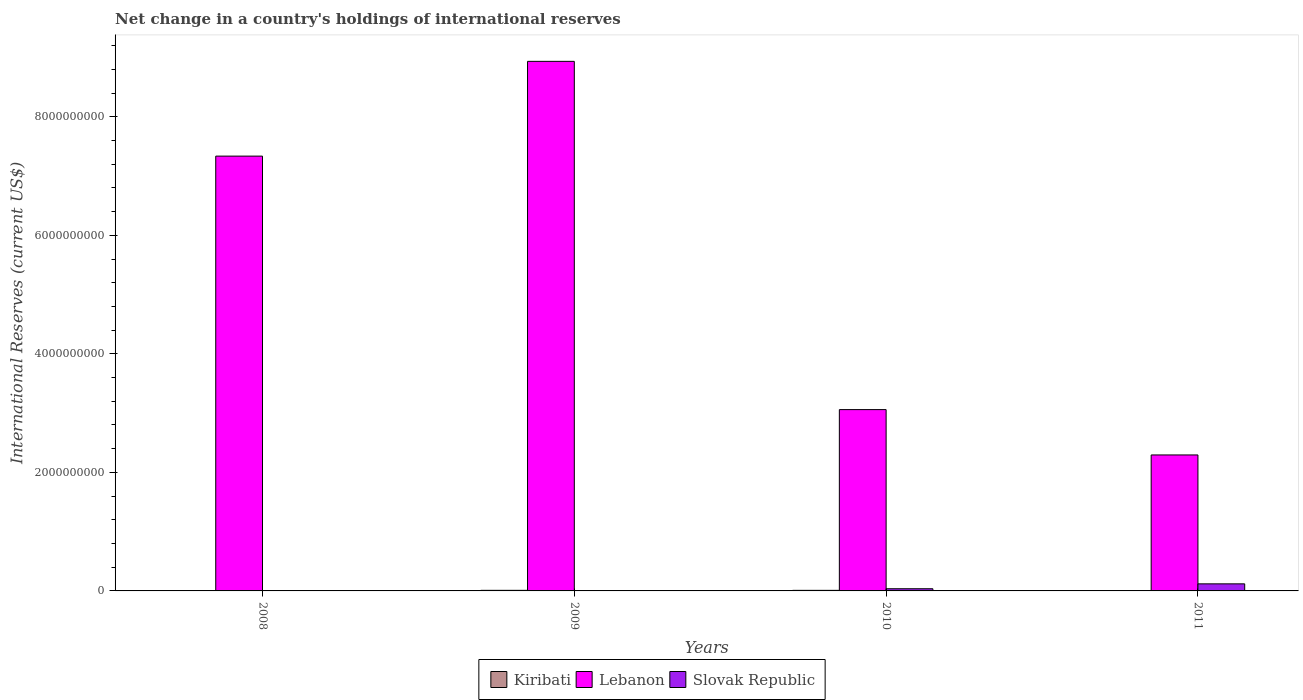How many different coloured bars are there?
Make the answer very short. 3. Are the number of bars per tick equal to the number of legend labels?
Keep it short and to the point. No. Are the number of bars on each tick of the X-axis equal?
Your answer should be very brief. No. How many bars are there on the 3rd tick from the left?
Keep it short and to the point. 3. How many bars are there on the 4th tick from the right?
Give a very brief answer. 2. In how many cases, is the number of bars for a given year not equal to the number of legend labels?
Provide a succinct answer. 2. Across all years, what is the maximum international reserves in Slovak Republic?
Offer a very short reply. 1.19e+08. What is the total international reserves in Lebanon in the graph?
Provide a short and direct response. 2.16e+1. What is the difference between the international reserves in Kiribati in 2008 and that in 2009?
Offer a very short reply. -3.36e+06. What is the difference between the international reserves in Lebanon in 2010 and the international reserves in Kiribati in 2009?
Offer a terse response. 3.05e+09. What is the average international reserves in Lebanon per year?
Your answer should be very brief. 5.41e+09. In the year 2009, what is the difference between the international reserves in Kiribati and international reserves in Lebanon?
Make the answer very short. -8.93e+09. What is the ratio of the international reserves in Kiribati in 2010 to that in 2011?
Make the answer very short. 4.87. Is the difference between the international reserves in Kiribati in 2009 and 2010 greater than the difference between the international reserves in Lebanon in 2009 and 2010?
Provide a short and direct response. No. What is the difference between the highest and the second highest international reserves in Lebanon?
Offer a terse response. 1.60e+09. What is the difference between the highest and the lowest international reserves in Lebanon?
Provide a succinct answer. 6.64e+09. Is the sum of the international reserves in Lebanon in 2009 and 2011 greater than the maximum international reserves in Kiribati across all years?
Your answer should be compact. Yes. Is it the case that in every year, the sum of the international reserves in Slovak Republic and international reserves in Lebanon is greater than the international reserves in Kiribati?
Your response must be concise. Yes. Are all the bars in the graph horizontal?
Ensure brevity in your answer.  No. Are the values on the major ticks of Y-axis written in scientific E-notation?
Make the answer very short. No. Does the graph contain any zero values?
Ensure brevity in your answer.  Yes. Does the graph contain grids?
Your answer should be very brief. No. What is the title of the graph?
Your response must be concise. Net change in a country's holdings of international reserves. Does "St. Kitts and Nevis" appear as one of the legend labels in the graph?
Offer a terse response. No. What is the label or title of the X-axis?
Give a very brief answer. Years. What is the label or title of the Y-axis?
Your response must be concise. International Reserves (current US$). What is the International Reserves (current US$) of Kiribati in 2008?
Provide a short and direct response. 6.53e+06. What is the International Reserves (current US$) of Lebanon in 2008?
Keep it short and to the point. 7.34e+09. What is the International Reserves (current US$) of Slovak Republic in 2008?
Your response must be concise. 0. What is the International Reserves (current US$) of Kiribati in 2009?
Your answer should be very brief. 9.89e+06. What is the International Reserves (current US$) in Lebanon in 2009?
Make the answer very short. 8.94e+09. What is the International Reserves (current US$) of Slovak Republic in 2009?
Your response must be concise. 0. What is the International Reserves (current US$) of Kiribati in 2010?
Ensure brevity in your answer.  9.50e+06. What is the International Reserves (current US$) of Lebanon in 2010?
Provide a succinct answer. 3.06e+09. What is the International Reserves (current US$) of Slovak Republic in 2010?
Your answer should be very brief. 3.67e+07. What is the International Reserves (current US$) of Kiribati in 2011?
Your answer should be compact. 1.95e+06. What is the International Reserves (current US$) of Lebanon in 2011?
Keep it short and to the point. 2.29e+09. What is the International Reserves (current US$) of Slovak Republic in 2011?
Provide a succinct answer. 1.19e+08. Across all years, what is the maximum International Reserves (current US$) in Kiribati?
Offer a terse response. 9.89e+06. Across all years, what is the maximum International Reserves (current US$) in Lebanon?
Give a very brief answer. 8.94e+09. Across all years, what is the maximum International Reserves (current US$) of Slovak Republic?
Offer a terse response. 1.19e+08. Across all years, what is the minimum International Reserves (current US$) in Kiribati?
Ensure brevity in your answer.  1.95e+06. Across all years, what is the minimum International Reserves (current US$) in Lebanon?
Provide a succinct answer. 2.29e+09. What is the total International Reserves (current US$) of Kiribati in the graph?
Your response must be concise. 2.79e+07. What is the total International Reserves (current US$) of Lebanon in the graph?
Your answer should be compact. 2.16e+1. What is the total International Reserves (current US$) of Slovak Republic in the graph?
Your answer should be compact. 1.56e+08. What is the difference between the International Reserves (current US$) in Kiribati in 2008 and that in 2009?
Your response must be concise. -3.36e+06. What is the difference between the International Reserves (current US$) in Lebanon in 2008 and that in 2009?
Offer a terse response. -1.60e+09. What is the difference between the International Reserves (current US$) in Kiribati in 2008 and that in 2010?
Give a very brief answer. -2.97e+06. What is the difference between the International Reserves (current US$) of Lebanon in 2008 and that in 2010?
Your answer should be very brief. 4.28e+09. What is the difference between the International Reserves (current US$) of Kiribati in 2008 and that in 2011?
Ensure brevity in your answer.  4.58e+06. What is the difference between the International Reserves (current US$) of Lebanon in 2008 and that in 2011?
Give a very brief answer. 5.04e+09. What is the difference between the International Reserves (current US$) of Kiribati in 2009 and that in 2010?
Offer a very short reply. 3.84e+05. What is the difference between the International Reserves (current US$) in Lebanon in 2009 and that in 2010?
Make the answer very short. 5.88e+09. What is the difference between the International Reserves (current US$) of Kiribati in 2009 and that in 2011?
Keep it short and to the point. 7.94e+06. What is the difference between the International Reserves (current US$) of Lebanon in 2009 and that in 2011?
Your response must be concise. 6.64e+09. What is the difference between the International Reserves (current US$) of Kiribati in 2010 and that in 2011?
Provide a short and direct response. 7.55e+06. What is the difference between the International Reserves (current US$) in Lebanon in 2010 and that in 2011?
Your response must be concise. 7.65e+08. What is the difference between the International Reserves (current US$) of Slovak Republic in 2010 and that in 2011?
Ensure brevity in your answer.  -8.25e+07. What is the difference between the International Reserves (current US$) of Kiribati in 2008 and the International Reserves (current US$) of Lebanon in 2009?
Provide a succinct answer. -8.93e+09. What is the difference between the International Reserves (current US$) of Kiribati in 2008 and the International Reserves (current US$) of Lebanon in 2010?
Keep it short and to the point. -3.05e+09. What is the difference between the International Reserves (current US$) in Kiribati in 2008 and the International Reserves (current US$) in Slovak Republic in 2010?
Ensure brevity in your answer.  -3.01e+07. What is the difference between the International Reserves (current US$) of Lebanon in 2008 and the International Reserves (current US$) of Slovak Republic in 2010?
Your answer should be compact. 7.30e+09. What is the difference between the International Reserves (current US$) of Kiribati in 2008 and the International Reserves (current US$) of Lebanon in 2011?
Make the answer very short. -2.29e+09. What is the difference between the International Reserves (current US$) in Kiribati in 2008 and the International Reserves (current US$) in Slovak Republic in 2011?
Ensure brevity in your answer.  -1.13e+08. What is the difference between the International Reserves (current US$) in Lebanon in 2008 and the International Reserves (current US$) in Slovak Republic in 2011?
Ensure brevity in your answer.  7.22e+09. What is the difference between the International Reserves (current US$) in Kiribati in 2009 and the International Reserves (current US$) in Lebanon in 2010?
Your response must be concise. -3.05e+09. What is the difference between the International Reserves (current US$) in Kiribati in 2009 and the International Reserves (current US$) in Slovak Republic in 2010?
Your response must be concise. -2.68e+07. What is the difference between the International Reserves (current US$) in Lebanon in 2009 and the International Reserves (current US$) in Slovak Republic in 2010?
Ensure brevity in your answer.  8.90e+09. What is the difference between the International Reserves (current US$) of Kiribati in 2009 and the International Reserves (current US$) of Lebanon in 2011?
Keep it short and to the point. -2.28e+09. What is the difference between the International Reserves (current US$) of Kiribati in 2009 and the International Reserves (current US$) of Slovak Republic in 2011?
Your answer should be compact. -1.09e+08. What is the difference between the International Reserves (current US$) of Lebanon in 2009 and the International Reserves (current US$) of Slovak Republic in 2011?
Give a very brief answer. 8.82e+09. What is the difference between the International Reserves (current US$) of Kiribati in 2010 and the International Reserves (current US$) of Lebanon in 2011?
Keep it short and to the point. -2.28e+09. What is the difference between the International Reserves (current US$) in Kiribati in 2010 and the International Reserves (current US$) in Slovak Republic in 2011?
Make the answer very short. -1.10e+08. What is the difference between the International Reserves (current US$) of Lebanon in 2010 and the International Reserves (current US$) of Slovak Republic in 2011?
Offer a very short reply. 2.94e+09. What is the average International Reserves (current US$) in Kiribati per year?
Your answer should be very brief. 6.97e+06. What is the average International Reserves (current US$) in Lebanon per year?
Offer a very short reply. 5.41e+09. What is the average International Reserves (current US$) of Slovak Republic per year?
Your response must be concise. 3.90e+07. In the year 2008, what is the difference between the International Reserves (current US$) of Kiribati and International Reserves (current US$) of Lebanon?
Give a very brief answer. -7.33e+09. In the year 2009, what is the difference between the International Reserves (current US$) in Kiribati and International Reserves (current US$) in Lebanon?
Ensure brevity in your answer.  -8.93e+09. In the year 2010, what is the difference between the International Reserves (current US$) in Kiribati and International Reserves (current US$) in Lebanon?
Give a very brief answer. -3.05e+09. In the year 2010, what is the difference between the International Reserves (current US$) of Kiribati and International Reserves (current US$) of Slovak Republic?
Keep it short and to the point. -2.72e+07. In the year 2010, what is the difference between the International Reserves (current US$) of Lebanon and International Reserves (current US$) of Slovak Republic?
Offer a terse response. 3.02e+09. In the year 2011, what is the difference between the International Reserves (current US$) in Kiribati and International Reserves (current US$) in Lebanon?
Your answer should be compact. -2.29e+09. In the year 2011, what is the difference between the International Reserves (current US$) of Kiribati and International Reserves (current US$) of Slovak Republic?
Ensure brevity in your answer.  -1.17e+08. In the year 2011, what is the difference between the International Reserves (current US$) in Lebanon and International Reserves (current US$) in Slovak Republic?
Your answer should be compact. 2.18e+09. What is the ratio of the International Reserves (current US$) of Kiribati in 2008 to that in 2009?
Your answer should be very brief. 0.66. What is the ratio of the International Reserves (current US$) of Lebanon in 2008 to that in 2009?
Keep it short and to the point. 0.82. What is the ratio of the International Reserves (current US$) of Kiribati in 2008 to that in 2010?
Your response must be concise. 0.69. What is the ratio of the International Reserves (current US$) in Lebanon in 2008 to that in 2010?
Offer a terse response. 2.4. What is the ratio of the International Reserves (current US$) of Kiribati in 2008 to that in 2011?
Offer a very short reply. 3.35. What is the ratio of the International Reserves (current US$) in Lebanon in 2008 to that in 2011?
Provide a succinct answer. 3.2. What is the ratio of the International Reserves (current US$) in Kiribati in 2009 to that in 2010?
Ensure brevity in your answer.  1.04. What is the ratio of the International Reserves (current US$) of Lebanon in 2009 to that in 2010?
Ensure brevity in your answer.  2.92. What is the ratio of the International Reserves (current US$) in Kiribati in 2009 to that in 2011?
Make the answer very short. 5.07. What is the ratio of the International Reserves (current US$) in Lebanon in 2009 to that in 2011?
Offer a very short reply. 3.89. What is the ratio of the International Reserves (current US$) in Kiribati in 2010 to that in 2011?
Your answer should be compact. 4.87. What is the ratio of the International Reserves (current US$) in Lebanon in 2010 to that in 2011?
Keep it short and to the point. 1.33. What is the ratio of the International Reserves (current US$) of Slovak Republic in 2010 to that in 2011?
Your answer should be compact. 0.31. What is the difference between the highest and the second highest International Reserves (current US$) in Kiribati?
Keep it short and to the point. 3.84e+05. What is the difference between the highest and the second highest International Reserves (current US$) of Lebanon?
Your answer should be compact. 1.60e+09. What is the difference between the highest and the lowest International Reserves (current US$) of Kiribati?
Provide a short and direct response. 7.94e+06. What is the difference between the highest and the lowest International Reserves (current US$) in Lebanon?
Offer a very short reply. 6.64e+09. What is the difference between the highest and the lowest International Reserves (current US$) of Slovak Republic?
Offer a very short reply. 1.19e+08. 